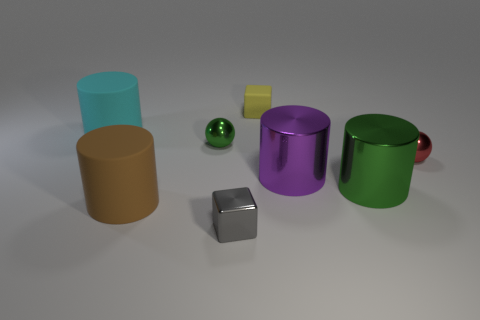Do the green metallic thing to the left of the big purple cylinder and the gray thing have the same shape?
Make the answer very short. No. What material is the purple cylinder?
Your answer should be very brief. Metal. What is the shape of the large object behind the small shiny sphere that is right of the cube in front of the red thing?
Your response must be concise. Cylinder. What number of other things are there of the same shape as the cyan matte object?
Your response must be concise. 3. How many big cyan matte cylinders are there?
Give a very brief answer. 1. What number of things are brown rubber cylinders or balls?
Your response must be concise. 3. There is a purple object; are there any metal things on the right side of it?
Make the answer very short. Yes. Is the number of brown matte objects that are in front of the big cyan rubber object greater than the number of cyan rubber cylinders to the right of the big brown rubber cylinder?
Give a very brief answer. Yes. What size is the green metallic object that is the same shape as the red thing?
Offer a very short reply. Small. How many blocks are big shiny things or large matte things?
Make the answer very short. 0. 